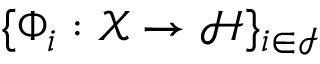<formula> <loc_0><loc_0><loc_500><loc_500>\{ \Phi _ { i } \colon \mathcal { X } \to \mathcal { H } \} _ { i \in \mathcal { I } }</formula> 